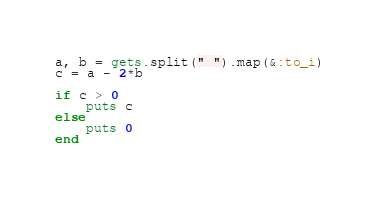<code> <loc_0><loc_0><loc_500><loc_500><_Ruby_>a, b = gets.split(" ").map(&:to_i)
c = a - 2*b

if c > 0
    puts c
else
    puts 0
end</code> 